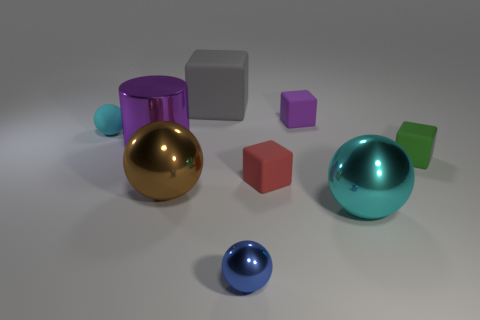Can you describe the textures present in the image? Certainly. The objects in the image have smooth and reflective textures. The spheres and cylinder have glossier surfaces which reflect light and highlights, indicating they might be made of materials like polished metal or plastic. 